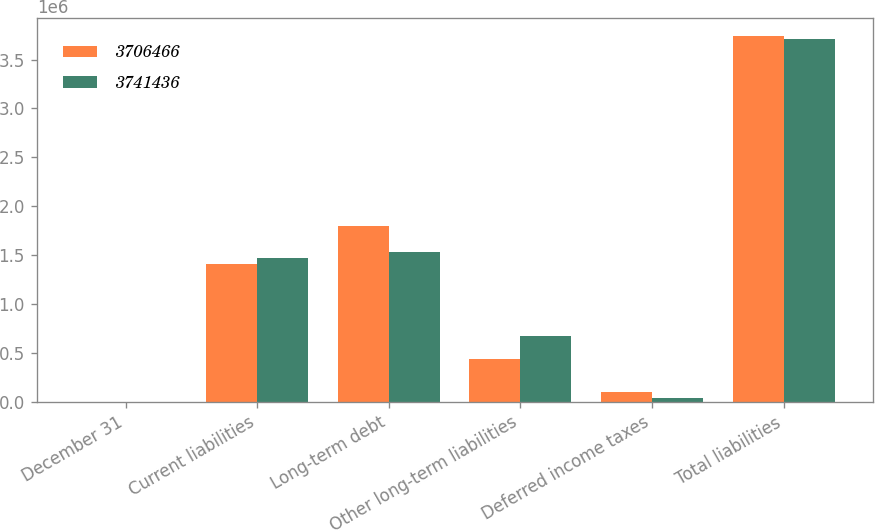Convert chart. <chart><loc_0><loc_0><loc_500><loc_500><stacked_bar_chart><ecel><fcel>December 31<fcel>Current liabilities<fcel>Long-term debt<fcel>Other long-term liabilities<fcel>Deferred income taxes<fcel>Total liabilities<nl><fcel>3.70647e+06<fcel>2013<fcel>1.40802e+06<fcel>1.79514e+06<fcel>434068<fcel>104204<fcel>3.74144e+06<nl><fcel>3.74144e+06<fcel>2012<fcel>1.47111e+06<fcel>1.53097e+06<fcel>668732<fcel>35657<fcel>3.70647e+06<nl></chart> 